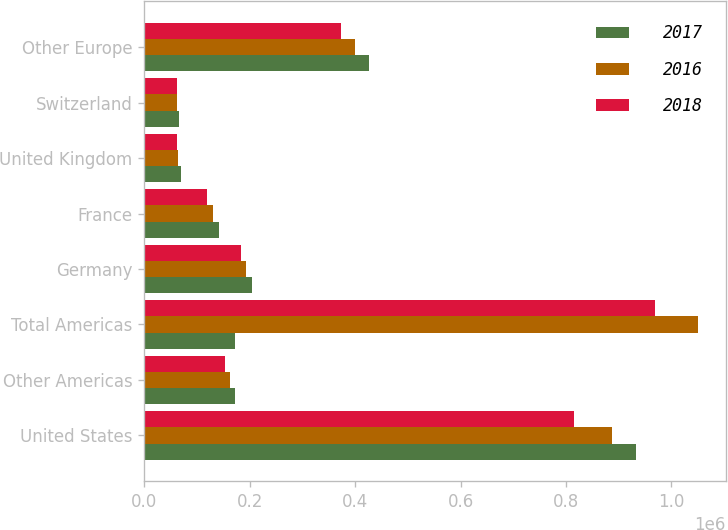<chart> <loc_0><loc_0><loc_500><loc_500><stacked_bar_chart><ecel><fcel>United States<fcel>Other Americas<fcel>Total Americas<fcel>Germany<fcel>France<fcel>United Kingdom<fcel>Switzerland<fcel>Other Europe<nl><fcel>2017<fcel>933419<fcel>172537<fcel>172537<fcel>205296<fcel>141513<fcel>70378<fcel>65377<fcel>426209<nl><fcel>2016<fcel>888241<fcel>162672<fcel>1.05091e+06<fcel>192126<fcel>130427<fcel>64361<fcel>63090<fcel>399923<nl><fcel>2018<fcel>815153<fcel>153607<fcel>968760<fcel>182644<fcel>118681<fcel>61513<fcel>62115<fcel>374008<nl></chart> 